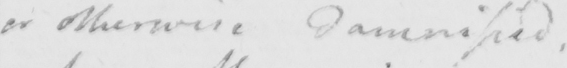Can you read and transcribe this handwriting? or otherwise damnified , 